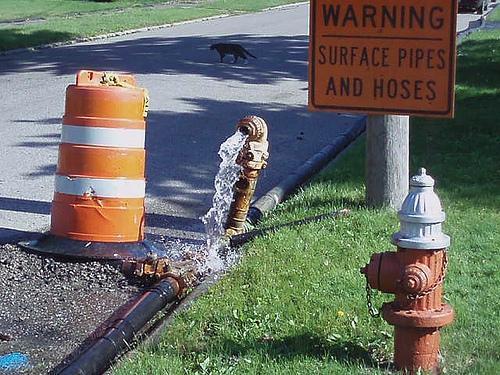How many signs are there?
Give a very brief answer. 1. 